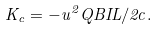<formula> <loc_0><loc_0><loc_500><loc_500>K _ { c } = - u ^ { 2 } Q B I L / 2 c .</formula> 